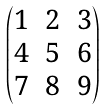Convert formula to latex. <formula><loc_0><loc_0><loc_500><loc_500>\begin{pmatrix} { 1 } & { 2 } & { 3 } \\ { 4 } & { 5 } & { 6 } \\ { 7 } & { 8 } & { 9 } \end{pmatrix}</formula> 